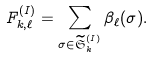<formula> <loc_0><loc_0><loc_500><loc_500>F _ { k , \ell } ^ { ( I ) } = \sum _ { \sigma \in \widetilde { \mathfrak S } _ { k } ^ { ( I ) } } \beta _ { \ell } ( \sigma ) .</formula> 